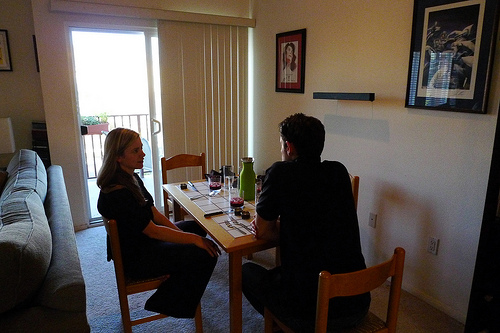<image>
Is there a chair in the man? No. The chair is not contained within the man. These objects have a different spatial relationship. 